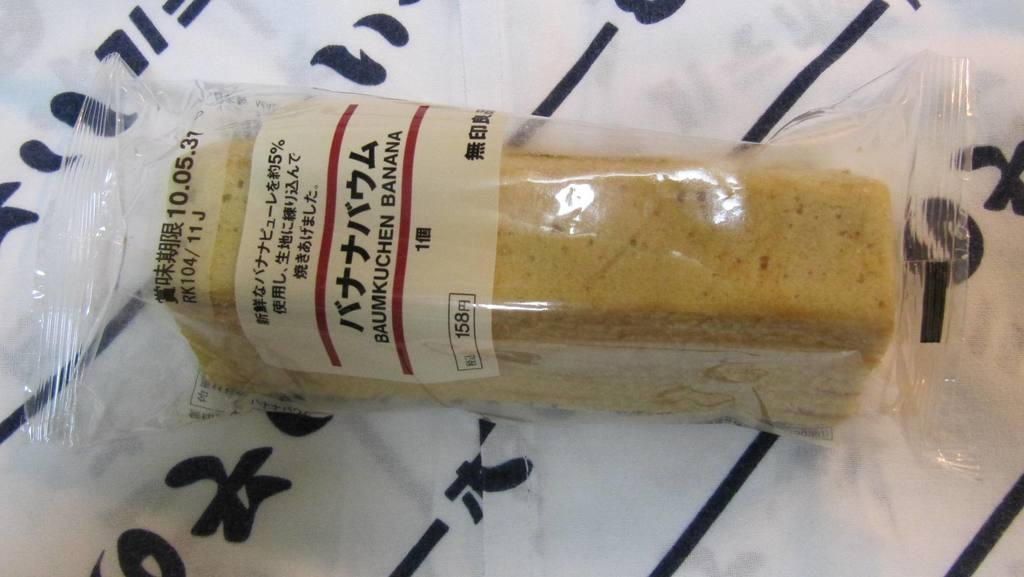<image>
Describe the image concisely. A package of some time of baked good says that it is Baumkuchen Banana. 